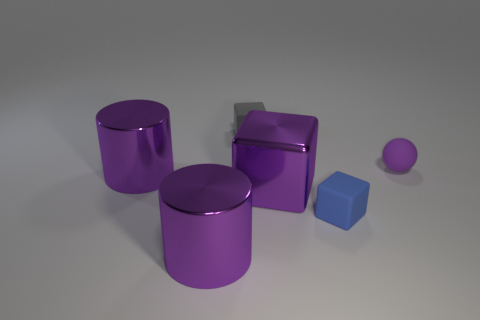There is a rubber thing that is the same color as the large block; what size is it?
Offer a very short reply. Small. There is a tiny blue rubber thing; is its shape the same as the small thing that is behind the small rubber ball?
Give a very brief answer. Yes. What is the color of the ball that is the same size as the blue matte object?
Your answer should be very brief. Purple. Is the number of tiny purple matte balls that are to the left of the small matte ball less than the number of purple blocks that are in front of the gray thing?
Provide a short and direct response. Yes. There is a blue thing in front of the large shiny cylinder behind the large metal thing right of the gray object; what shape is it?
Give a very brief answer. Cube. Does the tiny cube behind the ball have the same color as the object in front of the small blue rubber block?
Offer a very short reply. No. There is a small thing that is the same color as the large metallic cube; what is its shape?
Ensure brevity in your answer.  Sphere. How many metal things are either yellow balls or gray cubes?
Your response must be concise. 0. What is the color of the thing right of the rubber object in front of the cylinder behind the big purple block?
Your answer should be compact. Purple. What is the color of the other shiny thing that is the same shape as the blue object?
Provide a succinct answer. Purple. 